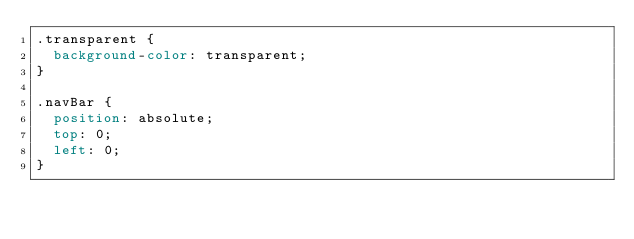Convert code to text. <code><loc_0><loc_0><loc_500><loc_500><_CSS_>.transparent {
  background-color: transparent;
}

.navBar {
  position: absolute;
  top: 0;
  left: 0;
}
</code> 